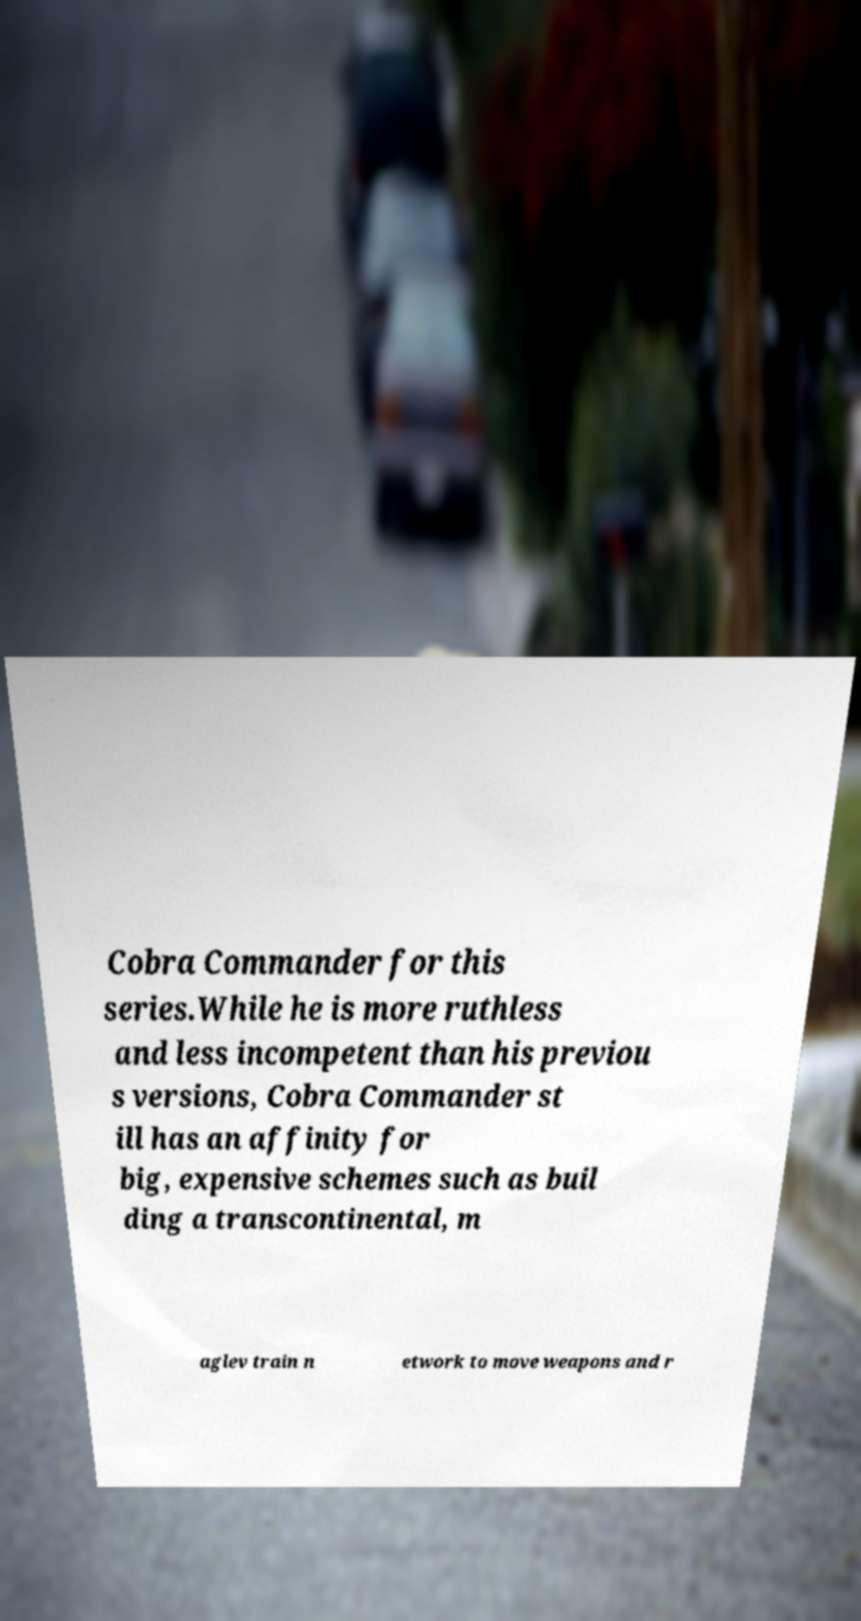What messages or text are displayed in this image? I need them in a readable, typed format. Cobra Commander for this series.While he is more ruthless and less incompetent than his previou s versions, Cobra Commander st ill has an affinity for big, expensive schemes such as buil ding a transcontinental, m aglev train n etwork to move weapons and r 